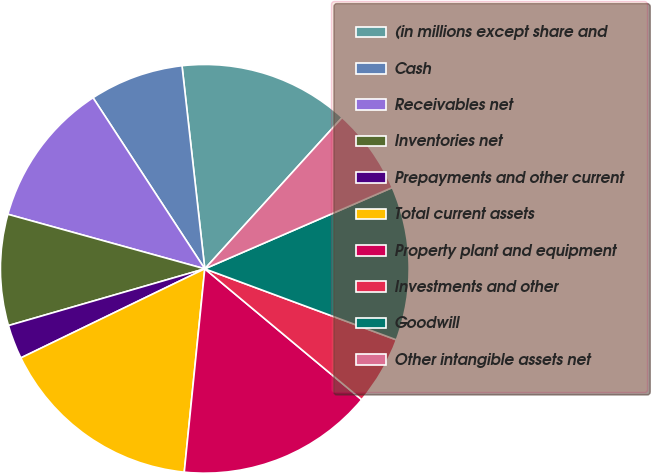Convert chart to OTSL. <chart><loc_0><loc_0><loc_500><loc_500><pie_chart><fcel>(in millions except share and<fcel>Cash<fcel>Receivables net<fcel>Inventories net<fcel>Prepayments and other current<fcel>Total current assets<fcel>Property plant and equipment<fcel>Investments and other<fcel>Goodwill<fcel>Other intangible assets net<nl><fcel>13.51%<fcel>7.43%<fcel>11.49%<fcel>8.78%<fcel>2.7%<fcel>16.22%<fcel>15.54%<fcel>5.41%<fcel>12.16%<fcel>6.76%<nl></chart> 